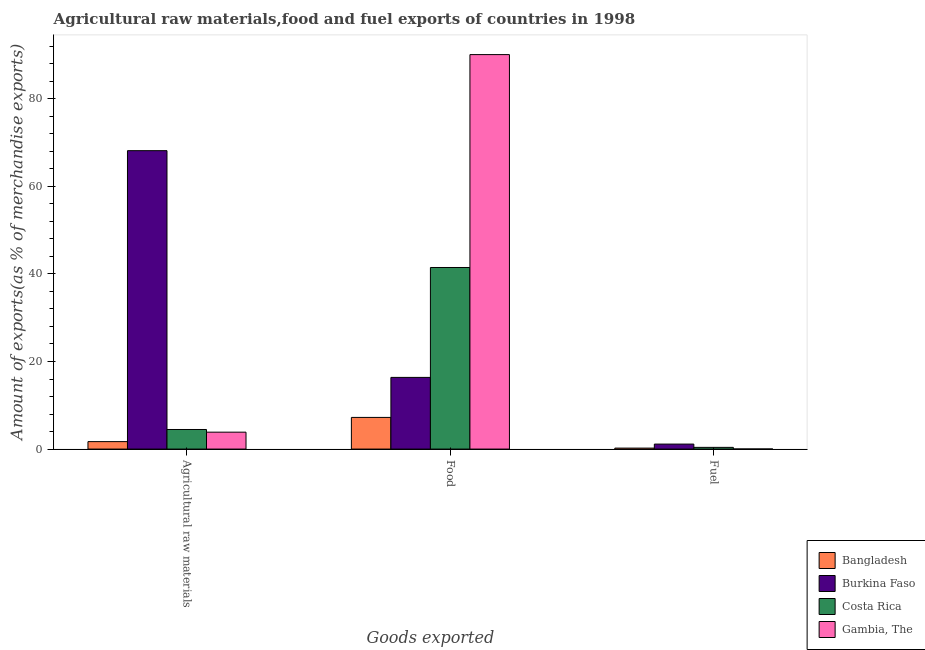How many different coloured bars are there?
Your response must be concise. 4. Are the number of bars on each tick of the X-axis equal?
Offer a terse response. Yes. How many bars are there on the 2nd tick from the left?
Make the answer very short. 4. What is the label of the 3rd group of bars from the left?
Offer a very short reply. Fuel. What is the percentage of raw materials exports in Bangladesh?
Your answer should be compact. 1.7. Across all countries, what is the maximum percentage of raw materials exports?
Your response must be concise. 68.14. Across all countries, what is the minimum percentage of food exports?
Give a very brief answer. 7.23. In which country was the percentage of fuel exports maximum?
Keep it short and to the point. Burkina Faso. In which country was the percentage of food exports minimum?
Keep it short and to the point. Bangladesh. What is the total percentage of raw materials exports in the graph?
Offer a terse response. 78.18. What is the difference between the percentage of food exports in Bangladesh and that in Gambia, The?
Your answer should be compact. -82.85. What is the difference between the percentage of raw materials exports in Bangladesh and the percentage of fuel exports in Gambia, The?
Offer a very short reply. 1.69. What is the average percentage of raw materials exports per country?
Provide a short and direct response. 19.55. What is the difference between the percentage of fuel exports and percentage of food exports in Burkina Faso?
Your answer should be very brief. -15.23. What is the ratio of the percentage of fuel exports in Gambia, The to that in Burkina Faso?
Your answer should be very brief. 0.02. Is the percentage of raw materials exports in Gambia, The less than that in Burkina Faso?
Provide a short and direct response. Yes. Is the difference between the percentage of fuel exports in Burkina Faso and Gambia, The greater than the difference between the percentage of raw materials exports in Burkina Faso and Gambia, The?
Offer a very short reply. No. What is the difference between the highest and the second highest percentage of raw materials exports?
Give a very brief answer. 63.67. What is the difference between the highest and the lowest percentage of fuel exports?
Offer a very short reply. 1.12. In how many countries, is the percentage of raw materials exports greater than the average percentage of raw materials exports taken over all countries?
Provide a short and direct response. 1. Is the sum of the percentage of food exports in Costa Rica and Burkina Faso greater than the maximum percentage of raw materials exports across all countries?
Give a very brief answer. No. What does the 3rd bar from the left in Fuel represents?
Your answer should be compact. Costa Rica. What does the 2nd bar from the right in Food represents?
Your answer should be compact. Costa Rica. How many bars are there?
Offer a very short reply. 12. How many countries are there in the graph?
Your answer should be compact. 4. Are the values on the major ticks of Y-axis written in scientific E-notation?
Keep it short and to the point. No. Does the graph contain grids?
Offer a terse response. No. How many legend labels are there?
Provide a short and direct response. 4. What is the title of the graph?
Keep it short and to the point. Agricultural raw materials,food and fuel exports of countries in 1998. Does "Comoros" appear as one of the legend labels in the graph?
Provide a succinct answer. No. What is the label or title of the X-axis?
Provide a succinct answer. Goods exported. What is the label or title of the Y-axis?
Your response must be concise. Amount of exports(as % of merchandise exports). What is the Amount of exports(as % of merchandise exports) in Bangladesh in Agricultural raw materials?
Provide a succinct answer. 1.7. What is the Amount of exports(as % of merchandise exports) in Burkina Faso in Agricultural raw materials?
Your answer should be compact. 68.14. What is the Amount of exports(as % of merchandise exports) in Costa Rica in Agricultural raw materials?
Your answer should be very brief. 4.47. What is the Amount of exports(as % of merchandise exports) in Gambia, The in Agricultural raw materials?
Give a very brief answer. 3.86. What is the Amount of exports(as % of merchandise exports) of Bangladesh in Food?
Keep it short and to the point. 7.23. What is the Amount of exports(as % of merchandise exports) in Burkina Faso in Food?
Offer a terse response. 16.37. What is the Amount of exports(as % of merchandise exports) in Costa Rica in Food?
Your answer should be very brief. 41.46. What is the Amount of exports(as % of merchandise exports) in Gambia, The in Food?
Your answer should be very brief. 90.08. What is the Amount of exports(as % of merchandise exports) in Bangladesh in Fuel?
Keep it short and to the point. 0.22. What is the Amount of exports(as % of merchandise exports) of Burkina Faso in Fuel?
Your answer should be compact. 1.14. What is the Amount of exports(as % of merchandise exports) in Costa Rica in Fuel?
Offer a very short reply. 0.39. What is the Amount of exports(as % of merchandise exports) of Gambia, The in Fuel?
Offer a terse response. 0.02. Across all Goods exported, what is the maximum Amount of exports(as % of merchandise exports) in Bangladesh?
Keep it short and to the point. 7.23. Across all Goods exported, what is the maximum Amount of exports(as % of merchandise exports) in Burkina Faso?
Give a very brief answer. 68.14. Across all Goods exported, what is the maximum Amount of exports(as % of merchandise exports) in Costa Rica?
Provide a short and direct response. 41.46. Across all Goods exported, what is the maximum Amount of exports(as % of merchandise exports) in Gambia, The?
Offer a terse response. 90.08. Across all Goods exported, what is the minimum Amount of exports(as % of merchandise exports) in Bangladesh?
Offer a very short reply. 0.22. Across all Goods exported, what is the minimum Amount of exports(as % of merchandise exports) of Burkina Faso?
Your response must be concise. 1.14. Across all Goods exported, what is the minimum Amount of exports(as % of merchandise exports) in Costa Rica?
Keep it short and to the point. 0.39. Across all Goods exported, what is the minimum Amount of exports(as % of merchandise exports) in Gambia, The?
Provide a succinct answer. 0.02. What is the total Amount of exports(as % of merchandise exports) of Bangladesh in the graph?
Make the answer very short. 9.16. What is the total Amount of exports(as % of merchandise exports) in Burkina Faso in the graph?
Offer a terse response. 85.65. What is the total Amount of exports(as % of merchandise exports) of Costa Rica in the graph?
Ensure brevity in your answer.  46.33. What is the total Amount of exports(as % of merchandise exports) in Gambia, The in the graph?
Keep it short and to the point. 93.96. What is the difference between the Amount of exports(as % of merchandise exports) of Bangladesh in Agricultural raw materials and that in Food?
Provide a short and direct response. -5.53. What is the difference between the Amount of exports(as % of merchandise exports) in Burkina Faso in Agricultural raw materials and that in Food?
Offer a terse response. 51.78. What is the difference between the Amount of exports(as % of merchandise exports) of Costa Rica in Agricultural raw materials and that in Food?
Your answer should be compact. -36.99. What is the difference between the Amount of exports(as % of merchandise exports) in Gambia, The in Agricultural raw materials and that in Food?
Offer a very short reply. -86.22. What is the difference between the Amount of exports(as % of merchandise exports) in Bangladesh in Agricultural raw materials and that in Fuel?
Offer a terse response. 1.48. What is the difference between the Amount of exports(as % of merchandise exports) in Burkina Faso in Agricultural raw materials and that in Fuel?
Your answer should be very brief. 67. What is the difference between the Amount of exports(as % of merchandise exports) of Costa Rica in Agricultural raw materials and that in Fuel?
Keep it short and to the point. 4.08. What is the difference between the Amount of exports(as % of merchandise exports) in Gambia, The in Agricultural raw materials and that in Fuel?
Make the answer very short. 3.84. What is the difference between the Amount of exports(as % of merchandise exports) in Bangladesh in Food and that in Fuel?
Your answer should be compact. 7.01. What is the difference between the Amount of exports(as % of merchandise exports) of Burkina Faso in Food and that in Fuel?
Provide a short and direct response. 15.23. What is the difference between the Amount of exports(as % of merchandise exports) in Costa Rica in Food and that in Fuel?
Make the answer very short. 41.07. What is the difference between the Amount of exports(as % of merchandise exports) in Gambia, The in Food and that in Fuel?
Keep it short and to the point. 90.06. What is the difference between the Amount of exports(as % of merchandise exports) in Bangladesh in Agricultural raw materials and the Amount of exports(as % of merchandise exports) in Burkina Faso in Food?
Your answer should be compact. -14.66. What is the difference between the Amount of exports(as % of merchandise exports) of Bangladesh in Agricultural raw materials and the Amount of exports(as % of merchandise exports) of Costa Rica in Food?
Make the answer very short. -39.76. What is the difference between the Amount of exports(as % of merchandise exports) of Bangladesh in Agricultural raw materials and the Amount of exports(as % of merchandise exports) of Gambia, The in Food?
Offer a very short reply. -88.38. What is the difference between the Amount of exports(as % of merchandise exports) of Burkina Faso in Agricultural raw materials and the Amount of exports(as % of merchandise exports) of Costa Rica in Food?
Your answer should be very brief. 26.68. What is the difference between the Amount of exports(as % of merchandise exports) in Burkina Faso in Agricultural raw materials and the Amount of exports(as % of merchandise exports) in Gambia, The in Food?
Provide a succinct answer. -21.94. What is the difference between the Amount of exports(as % of merchandise exports) in Costa Rica in Agricultural raw materials and the Amount of exports(as % of merchandise exports) in Gambia, The in Food?
Provide a succinct answer. -85.61. What is the difference between the Amount of exports(as % of merchandise exports) of Bangladesh in Agricultural raw materials and the Amount of exports(as % of merchandise exports) of Burkina Faso in Fuel?
Offer a very short reply. 0.56. What is the difference between the Amount of exports(as % of merchandise exports) of Bangladesh in Agricultural raw materials and the Amount of exports(as % of merchandise exports) of Costa Rica in Fuel?
Make the answer very short. 1.31. What is the difference between the Amount of exports(as % of merchandise exports) of Bangladesh in Agricultural raw materials and the Amount of exports(as % of merchandise exports) of Gambia, The in Fuel?
Offer a very short reply. 1.69. What is the difference between the Amount of exports(as % of merchandise exports) of Burkina Faso in Agricultural raw materials and the Amount of exports(as % of merchandise exports) of Costa Rica in Fuel?
Provide a short and direct response. 67.75. What is the difference between the Amount of exports(as % of merchandise exports) in Burkina Faso in Agricultural raw materials and the Amount of exports(as % of merchandise exports) in Gambia, The in Fuel?
Offer a very short reply. 68.13. What is the difference between the Amount of exports(as % of merchandise exports) of Costa Rica in Agricultural raw materials and the Amount of exports(as % of merchandise exports) of Gambia, The in Fuel?
Give a very brief answer. 4.45. What is the difference between the Amount of exports(as % of merchandise exports) in Bangladesh in Food and the Amount of exports(as % of merchandise exports) in Burkina Faso in Fuel?
Provide a short and direct response. 6.09. What is the difference between the Amount of exports(as % of merchandise exports) in Bangladesh in Food and the Amount of exports(as % of merchandise exports) in Costa Rica in Fuel?
Keep it short and to the point. 6.84. What is the difference between the Amount of exports(as % of merchandise exports) in Bangladesh in Food and the Amount of exports(as % of merchandise exports) in Gambia, The in Fuel?
Make the answer very short. 7.21. What is the difference between the Amount of exports(as % of merchandise exports) of Burkina Faso in Food and the Amount of exports(as % of merchandise exports) of Costa Rica in Fuel?
Your response must be concise. 15.98. What is the difference between the Amount of exports(as % of merchandise exports) of Burkina Faso in Food and the Amount of exports(as % of merchandise exports) of Gambia, The in Fuel?
Make the answer very short. 16.35. What is the difference between the Amount of exports(as % of merchandise exports) in Costa Rica in Food and the Amount of exports(as % of merchandise exports) in Gambia, The in Fuel?
Keep it short and to the point. 41.45. What is the average Amount of exports(as % of merchandise exports) in Bangladesh per Goods exported?
Provide a succinct answer. 3.05. What is the average Amount of exports(as % of merchandise exports) of Burkina Faso per Goods exported?
Your answer should be compact. 28.55. What is the average Amount of exports(as % of merchandise exports) in Costa Rica per Goods exported?
Offer a very short reply. 15.44. What is the average Amount of exports(as % of merchandise exports) of Gambia, The per Goods exported?
Your answer should be compact. 31.32. What is the difference between the Amount of exports(as % of merchandise exports) in Bangladesh and Amount of exports(as % of merchandise exports) in Burkina Faso in Agricultural raw materials?
Give a very brief answer. -66.44. What is the difference between the Amount of exports(as % of merchandise exports) of Bangladesh and Amount of exports(as % of merchandise exports) of Costa Rica in Agricultural raw materials?
Keep it short and to the point. -2.77. What is the difference between the Amount of exports(as % of merchandise exports) of Bangladesh and Amount of exports(as % of merchandise exports) of Gambia, The in Agricultural raw materials?
Keep it short and to the point. -2.16. What is the difference between the Amount of exports(as % of merchandise exports) in Burkina Faso and Amount of exports(as % of merchandise exports) in Costa Rica in Agricultural raw materials?
Make the answer very short. 63.67. What is the difference between the Amount of exports(as % of merchandise exports) in Burkina Faso and Amount of exports(as % of merchandise exports) in Gambia, The in Agricultural raw materials?
Your response must be concise. 64.28. What is the difference between the Amount of exports(as % of merchandise exports) of Costa Rica and Amount of exports(as % of merchandise exports) of Gambia, The in Agricultural raw materials?
Keep it short and to the point. 0.61. What is the difference between the Amount of exports(as % of merchandise exports) in Bangladesh and Amount of exports(as % of merchandise exports) in Burkina Faso in Food?
Your answer should be very brief. -9.14. What is the difference between the Amount of exports(as % of merchandise exports) of Bangladesh and Amount of exports(as % of merchandise exports) of Costa Rica in Food?
Make the answer very short. -34.23. What is the difference between the Amount of exports(as % of merchandise exports) in Bangladesh and Amount of exports(as % of merchandise exports) in Gambia, The in Food?
Keep it short and to the point. -82.85. What is the difference between the Amount of exports(as % of merchandise exports) of Burkina Faso and Amount of exports(as % of merchandise exports) of Costa Rica in Food?
Provide a succinct answer. -25.1. What is the difference between the Amount of exports(as % of merchandise exports) of Burkina Faso and Amount of exports(as % of merchandise exports) of Gambia, The in Food?
Ensure brevity in your answer.  -73.71. What is the difference between the Amount of exports(as % of merchandise exports) in Costa Rica and Amount of exports(as % of merchandise exports) in Gambia, The in Food?
Offer a very short reply. -48.62. What is the difference between the Amount of exports(as % of merchandise exports) in Bangladesh and Amount of exports(as % of merchandise exports) in Burkina Faso in Fuel?
Provide a succinct answer. -0.92. What is the difference between the Amount of exports(as % of merchandise exports) of Bangladesh and Amount of exports(as % of merchandise exports) of Costa Rica in Fuel?
Offer a terse response. -0.17. What is the difference between the Amount of exports(as % of merchandise exports) of Bangladesh and Amount of exports(as % of merchandise exports) of Gambia, The in Fuel?
Ensure brevity in your answer.  0.2. What is the difference between the Amount of exports(as % of merchandise exports) in Burkina Faso and Amount of exports(as % of merchandise exports) in Costa Rica in Fuel?
Ensure brevity in your answer.  0.75. What is the difference between the Amount of exports(as % of merchandise exports) in Burkina Faso and Amount of exports(as % of merchandise exports) in Gambia, The in Fuel?
Your answer should be very brief. 1.12. What is the difference between the Amount of exports(as % of merchandise exports) in Costa Rica and Amount of exports(as % of merchandise exports) in Gambia, The in Fuel?
Ensure brevity in your answer.  0.37. What is the ratio of the Amount of exports(as % of merchandise exports) in Bangladesh in Agricultural raw materials to that in Food?
Your answer should be very brief. 0.24. What is the ratio of the Amount of exports(as % of merchandise exports) of Burkina Faso in Agricultural raw materials to that in Food?
Your response must be concise. 4.16. What is the ratio of the Amount of exports(as % of merchandise exports) of Costa Rica in Agricultural raw materials to that in Food?
Ensure brevity in your answer.  0.11. What is the ratio of the Amount of exports(as % of merchandise exports) in Gambia, The in Agricultural raw materials to that in Food?
Give a very brief answer. 0.04. What is the ratio of the Amount of exports(as % of merchandise exports) of Bangladesh in Agricultural raw materials to that in Fuel?
Give a very brief answer. 7.67. What is the ratio of the Amount of exports(as % of merchandise exports) of Burkina Faso in Agricultural raw materials to that in Fuel?
Ensure brevity in your answer.  59.74. What is the ratio of the Amount of exports(as % of merchandise exports) of Costa Rica in Agricultural raw materials to that in Fuel?
Provide a short and direct response. 11.48. What is the ratio of the Amount of exports(as % of merchandise exports) in Gambia, The in Agricultural raw materials to that in Fuel?
Give a very brief answer. 222.05. What is the ratio of the Amount of exports(as % of merchandise exports) in Bangladesh in Food to that in Fuel?
Keep it short and to the point. 32.53. What is the ratio of the Amount of exports(as % of merchandise exports) in Burkina Faso in Food to that in Fuel?
Provide a succinct answer. 14.35. What is the ratio of the Amount of exports(as % of merchandise exports) of Costa Rica in Food to that in Fuel?
Provide a short and direct response. 106.41. What is the ratio of the Amount of exports(as % of merchandise exports) in Gambia, The in Food to that in Fuel?
Provide a succinct answer. 5179.66. What is the difference between the highest and the second highest Amount of exports(as % of merchandise exports) of Bangladesh?
Offer a terse response. 5.53. What is the difference between the highest and the second highest Amount of exports(as % of merchandise exports) of Burkina Faso?
Give a very brief answer. 51.78. What is the difference between the highest and the second highest Amount of exports(as % of merchandise exports) of Costa Rica?
Your answer should be very brief. 36.99. What is the difference between the highest and the second highest Amount of exports(as % of merchandise exports) in Gambia, The?
Give a very brief answer. 86.22. What is the difference between the highest and the lowest Amount of exports(as % of merchandise exports) in Bangladesh?
Your answer should be very brief. 7.01. What is the difference between the highest and the lowest Amount of exports(as % of merchandise exports) in Burkina Faso?
Ensure brevity in your answer.  67. What is the difference between the highest and the lowest Amount of exports(as % of merchandise exports) of Costa Rica?
Keep it short and to the point. 41.07. What is the difference between the highest and the lowest Amount of exports(as % of merchandise exports) of Gambia, The?
Make the answer very short. 90.06. 